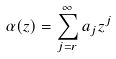Convert formula to latex. <formula><loc_0><loc_0><loc_500><loc_500>\alpha ( z ) = \sum _ { j = r } ^ { \infty } a _ { j } z ^ { j }</formula> 